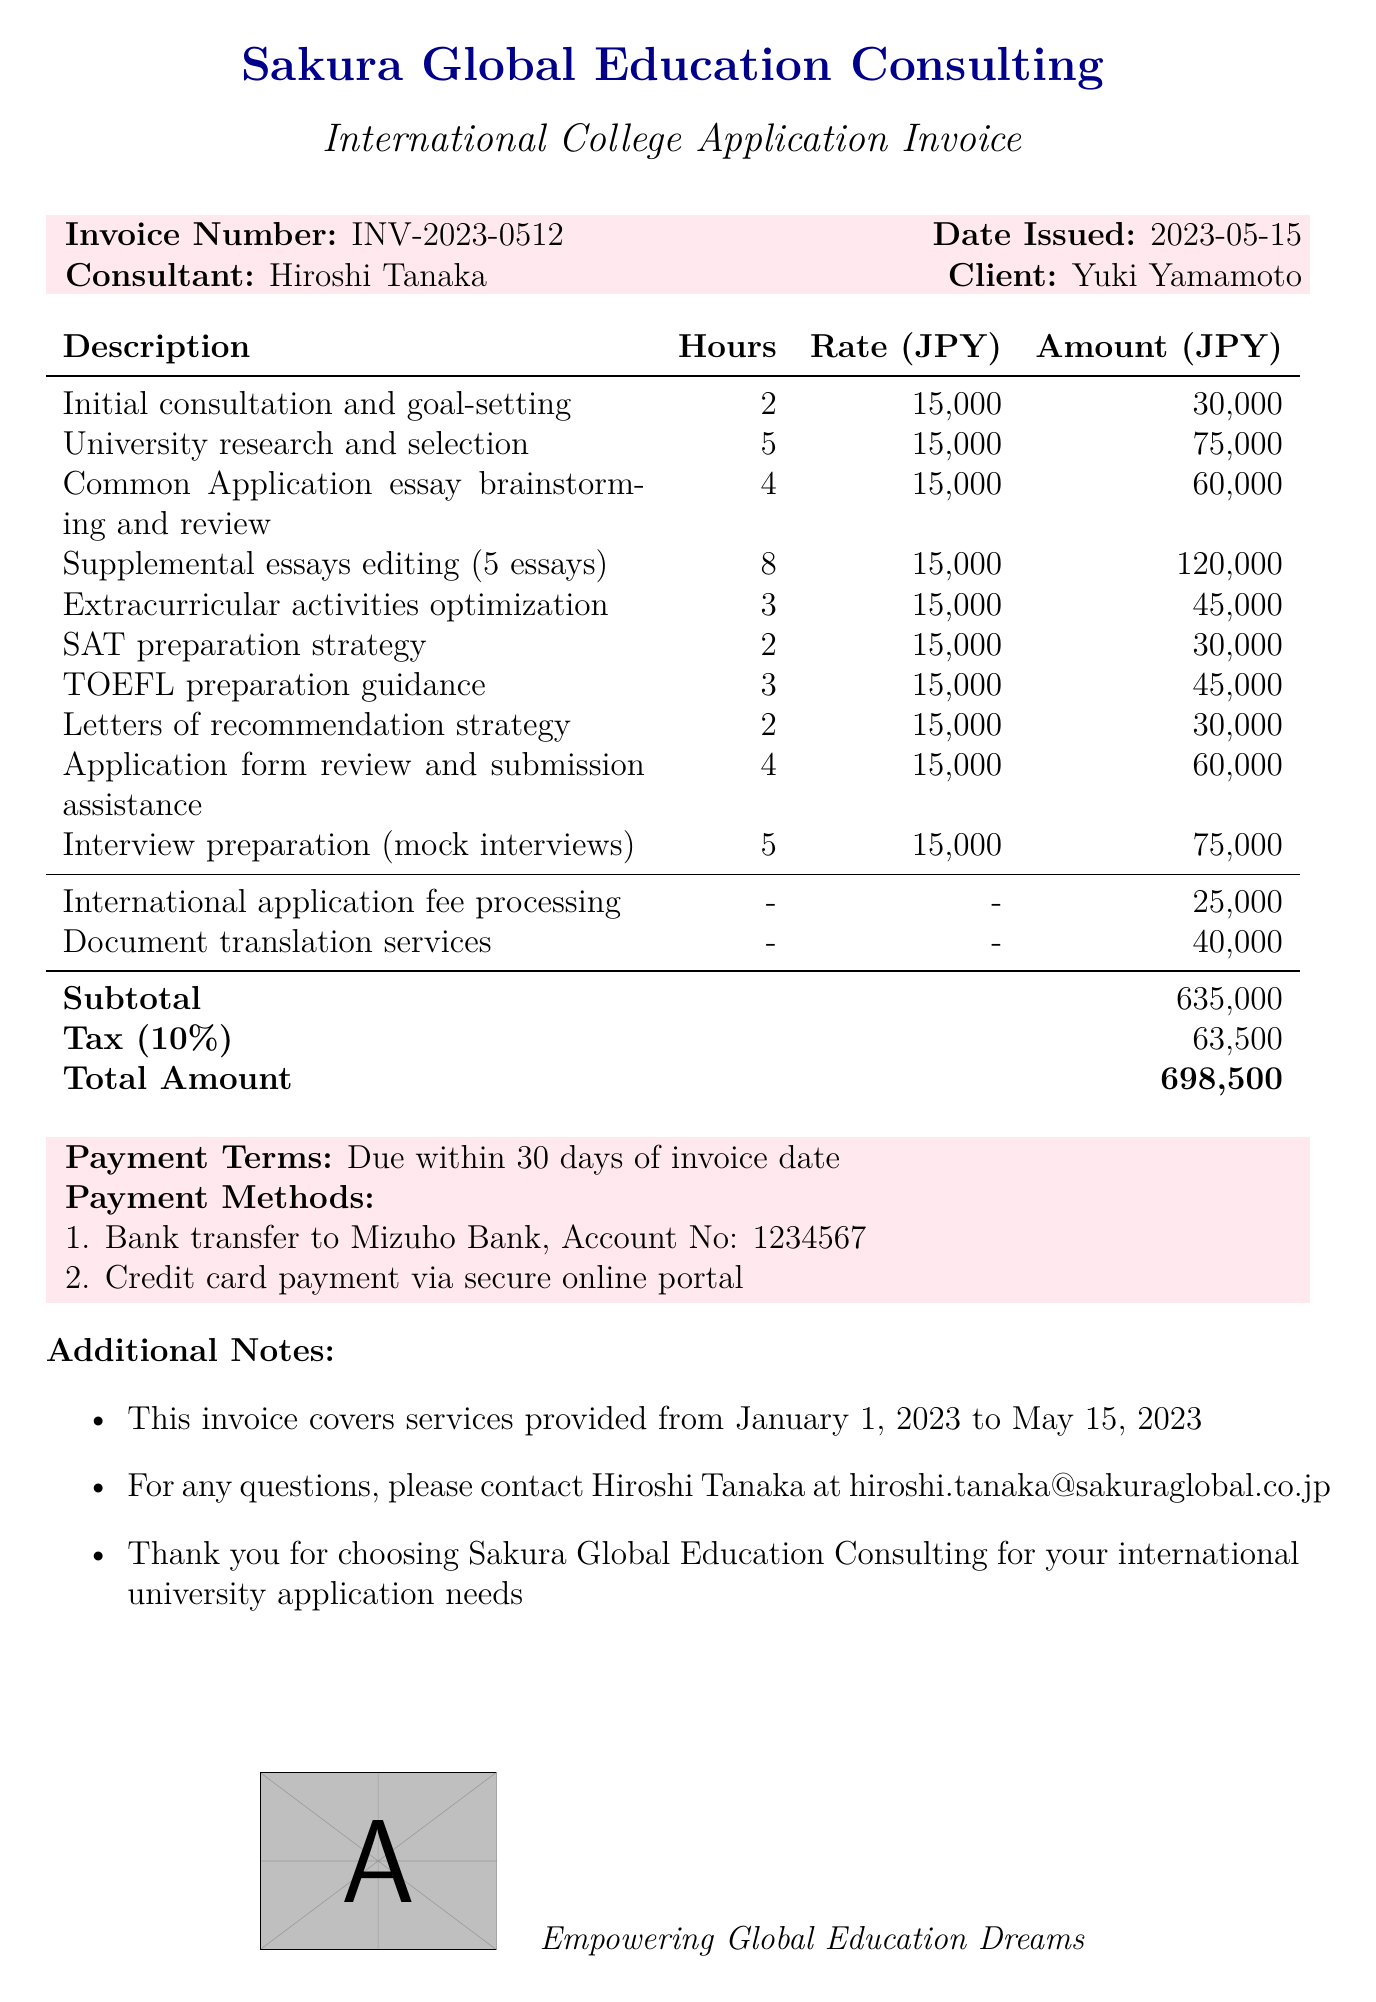What is the consultant's name? The consultant's name is listed at the top of the document as Hiroshi Tanaka.
Answer: Hiroshi Tanaka What is the invoice number? The invoice number is specified in the document, which is INV-2023-0512.
Answer: INV-2023-0512 How many hours were spent on university research and selection? The document provides the number of hours for university research and selection, which is indicated as 5 hours.
Answer: 5 What is the total amount due? The total amount due is calculated and presented at the end of the document, which is 698,500 JPY.
Answer: 698,500 What is the tax rate applied in the invoice? The tax rate is specifically mentioned in the document as 10%.
Answer: 10% What is the payment term specified? The payment term is explicitly stated in the document, which is due within 30 days of the invoice date.
Answer: Due within 30 days How much was charged for document translation services? The amount charged for document translation services is detailed in the document, which is 40,000 JPY.
Answer: 40,000 Which payment methods are accepted? The document lists the accepted payment methods, which are bank transfer and credit card payment.
Answer: Bank transfer, Credit card payment What is the duration of service coverage mentioned in the invoice? The duration of service coverage is noted in the document, covering from January 1, 2023, to May 15, 2023.
Answer: January 1, 2023 to May 15, 2023 